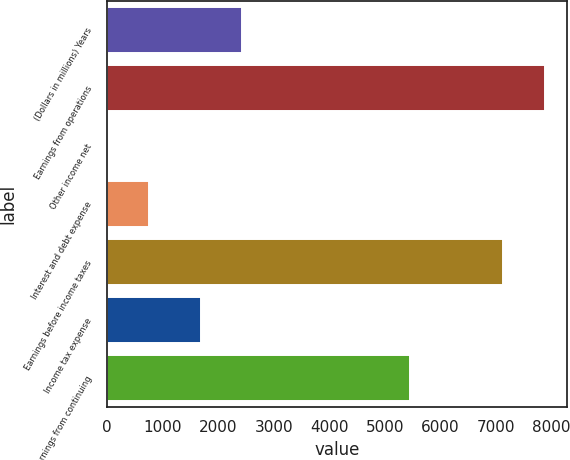<chart> <loc_0><loc_0><loc_500><loc_500><bar_chart><fcel>(Dollars in millions) Years<fcel>Earnings from operations<fcel>Other income net<fcel>Interest and debt expense<fcel>Earnings before income taxes<fcel>Income tax expense<fcel>Net earnings from continuing<nl><fcel>2438<fcel>7884<fcel>3<fcel>750<fcel>7137<fcel>1691<fcel>5446<nl></chart> 